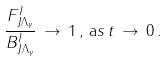<formula> <loc_0><loc_0><loc_500><loc_500>\frac { F ^ { I } _ { J \Lambda _ { \gamma } } } { B ^ { I } _ { J \Lambda _ { \gamma } } } \, \rightarrow \, 1 \, , \, { \mathrm a s } \, t \, \rightarrow \, 0 \, .</formula> 